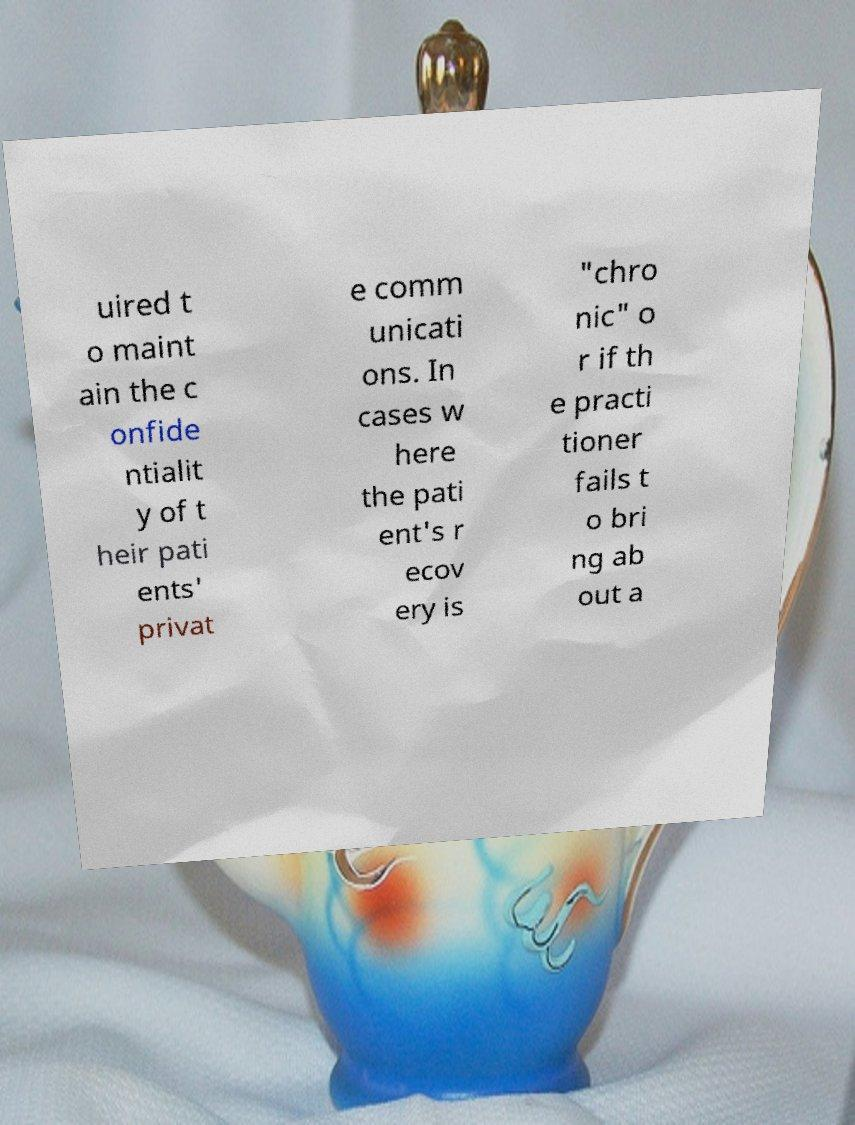Please read and relay the text visible in this image. What does it say? uired t o maint ain the c onfide ntialit y of t heir pati ents' privat e comm unicati ons. In cases w here the pati ent's r ecov ery is "chro nic" o r if th e practi tioner fails t o bri ng ab out a 